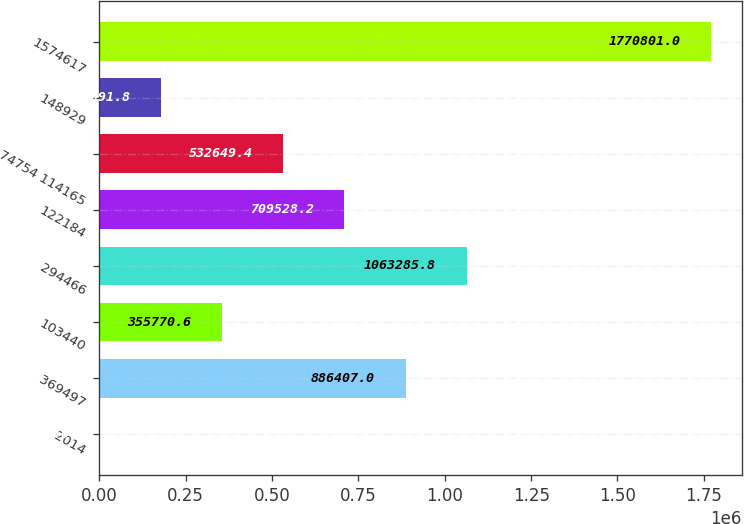Convert chart. <chart><loc_0><loc_0><loc_500><loc_500><bar_chart><fcel>2014<fcel>369497<fcel>103440<fcel>294466<fcel>122184<fcel>74754 114165<fcel>148929<fcel>1574617<nl><fcel>2013<fcel>886407<fcel>355771<fcel>1.06329e+06<fcel>709528<fcel>532649<fcel>178892<fcel>1.7708e+06<nl></chart> 